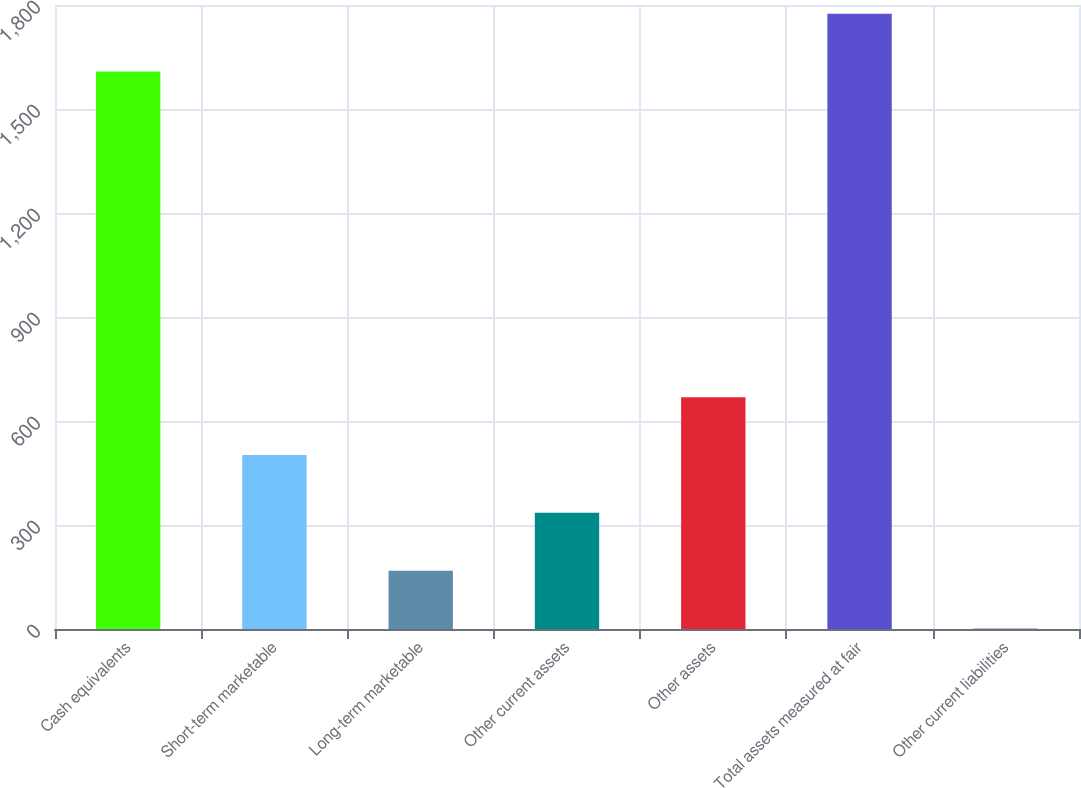<chart> <loc_0><loc_0><loc_500><loc_500><bar_chart><fcel>Cash equivalents<fcel>Short-term marketable<fcel>Long-term marketable<fcel>Other current assets<fcel>Other assets<fcel>Total assets measured at fair<fcel>Other current liabilities<nl><fcel>1608<fcel>501.75<fcel>168.25<fcel>335<fcel>668.5<fcel>1774.75<fcel>1.5<nl></chart> 